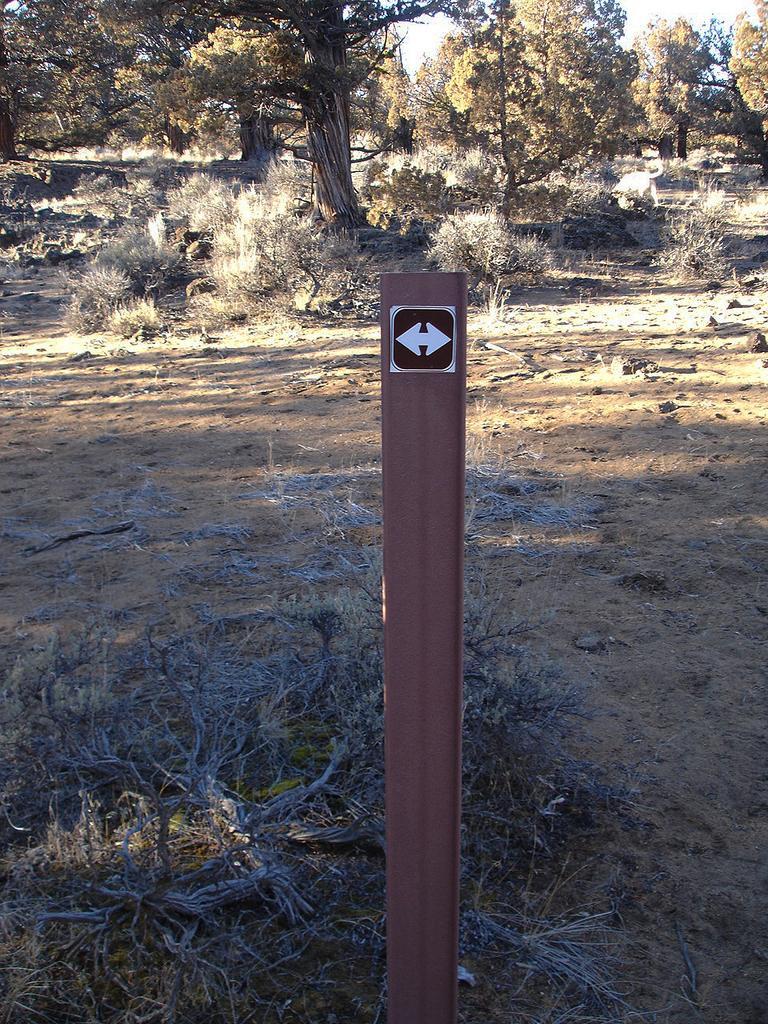Please provide a concise description of this image. In this picture we can see a pole and behind the pole there are plants, trees and a sky. 